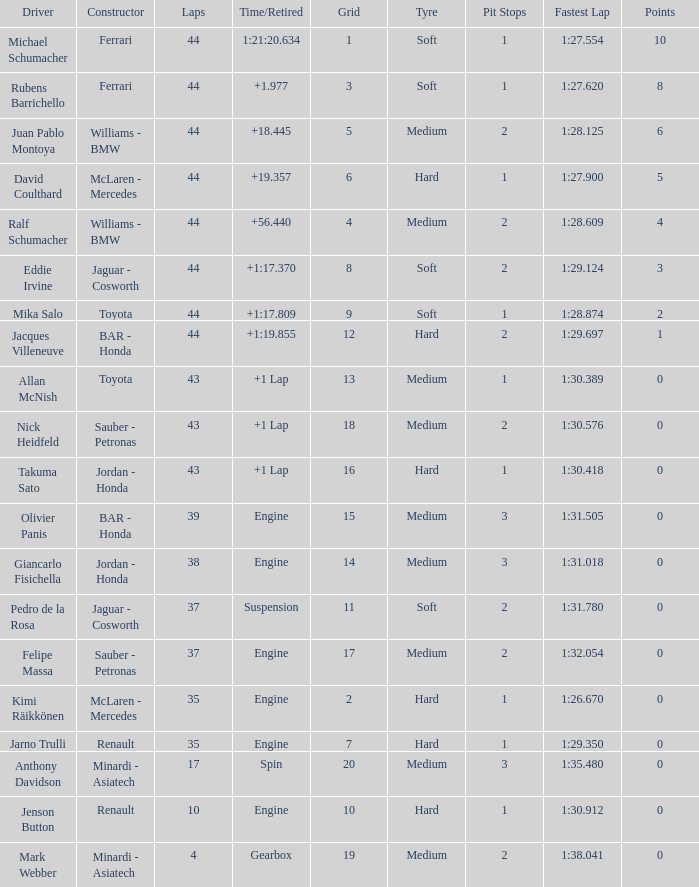What was the fewest laps for somone who finished +18.445? 44.0. 